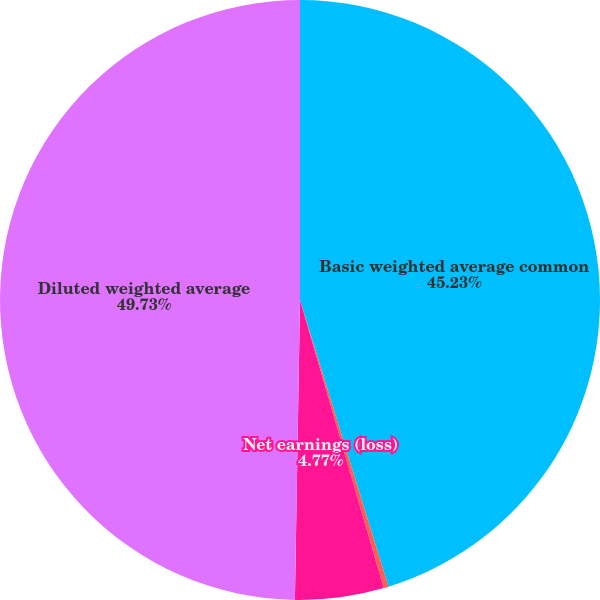Convert chart. <chart><loc_0><loc_0><loc_500><loc_500><pie_chart><fcel>Basic weighted average common<fcel>Earnings (loss) before<fcel>Net earnings (loss)<fcel>Diluted weighted average<nl><fcel>45.23%<fcel>0.27%<fcel>4.77%<fcel>49.73%<nl></chart> 